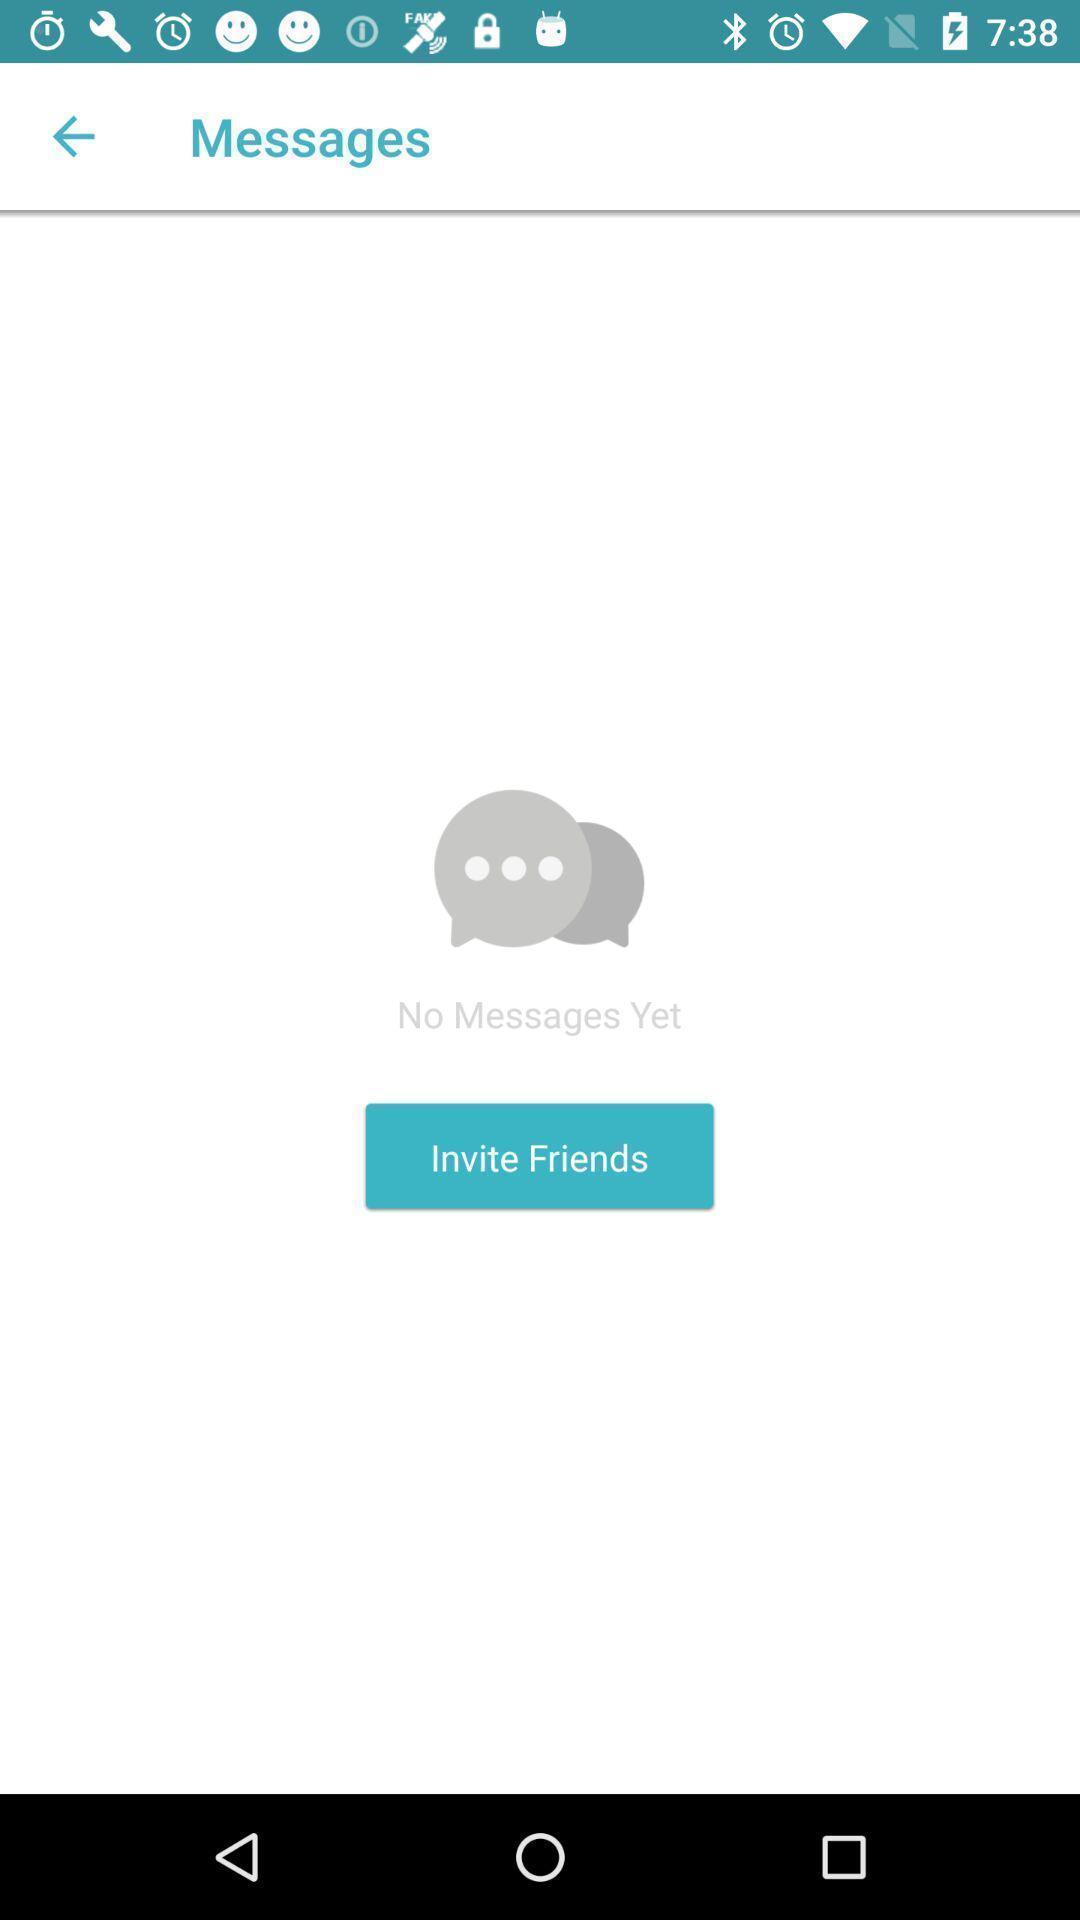Describe the visual elements of this screenshot. Screen displaying no messages found under messages. 